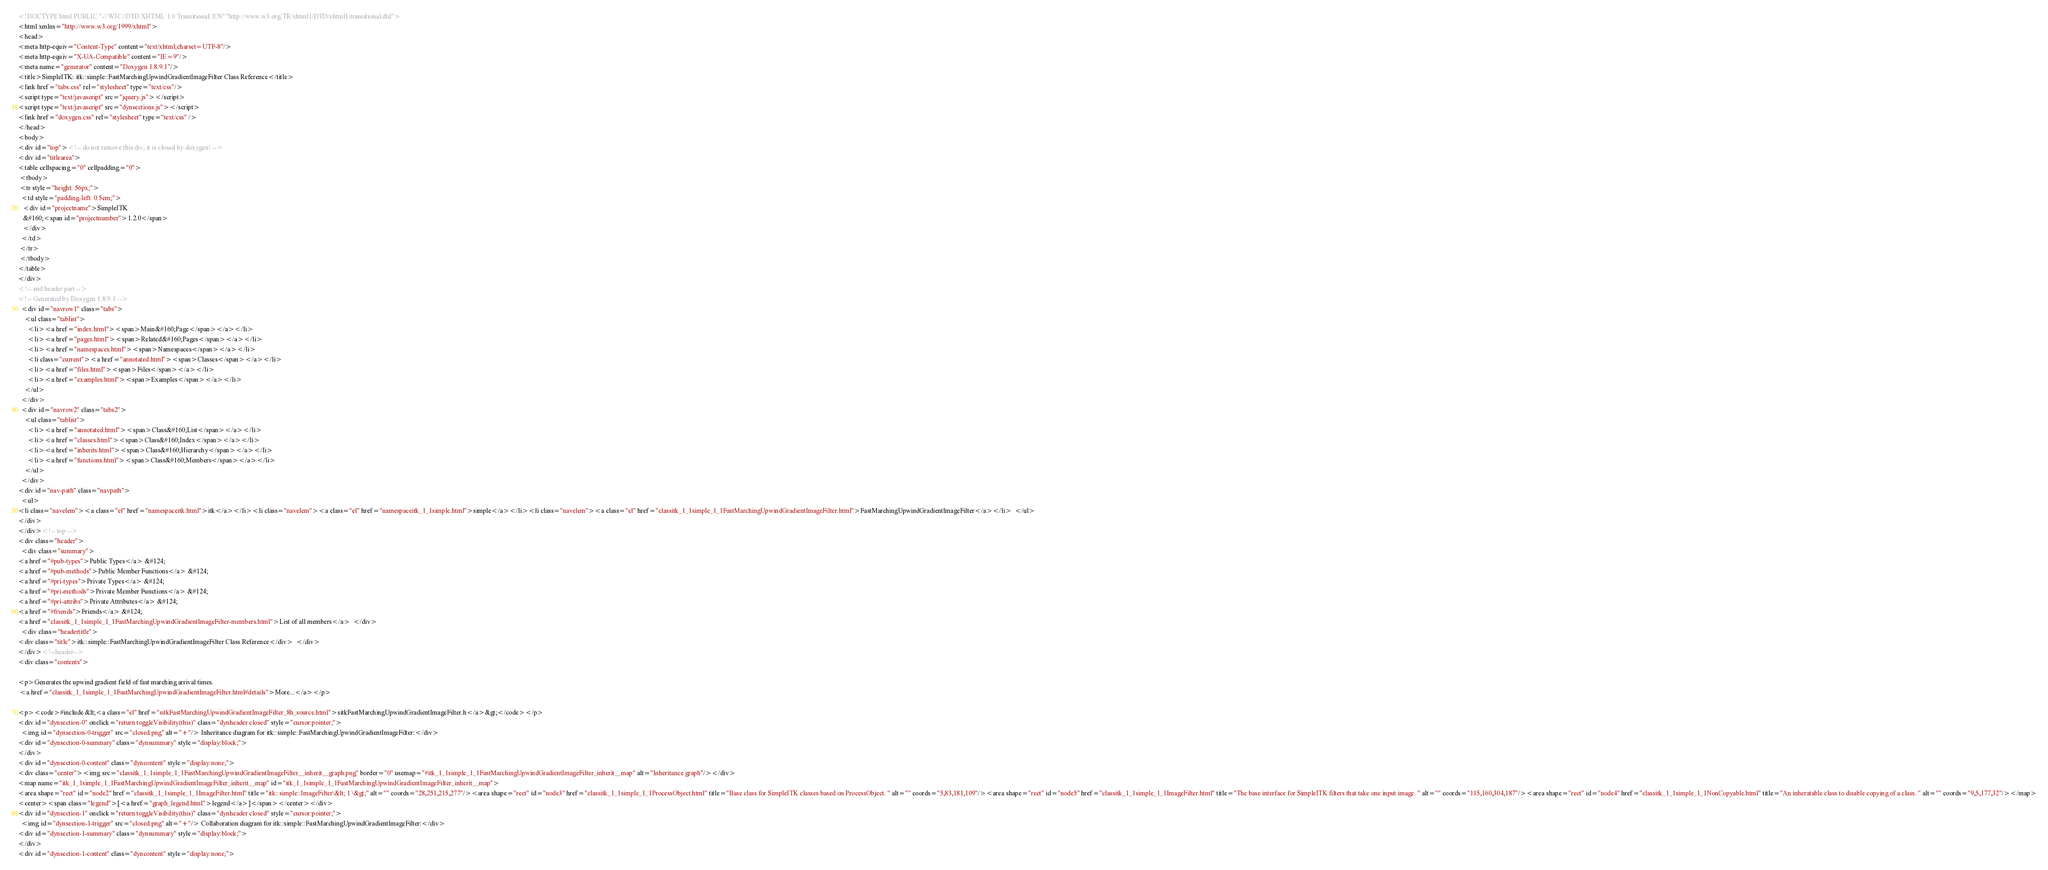Convert code to text. <code><loc_0><loc_0><loc_500><loc_500><_HTML_><!DOCTYPE html PUBLIC "-//W3C//DTD XHTML 1.0 Transitional//EN" "http://www.w3.org/TR/xhtml1/DTD/xhtml1-transitional.dtd">
<html xmlns="http://www.w3.org/1999/xhtml">
<head>
<meta http-equiv="Content-Type" content="text/xhtml;charset=UTF-8"/>
<meta http-equiv="X-UA-Compatible" content="IE=9"/>
<meta name="generator" content="Doxygen 1.8.9.1"/>
<title>SimpleITK: itk::simple::FastMarchingUpwindGradientImageFilter Class Reference</title>
<link href="tabs.css" rel="stylesheet" type="text/css"/>
<script type="text/javascript" src="jquery.js"></script>
<script type="text/javascript" src="dynsections.js"></script>
<link href="doxygen.css" rel="stylesheet" type="text/css" />
</head>
<body>
<div id="top"><!-- do not remove this div, it is closed by doxygen! -->
<div id="titlearea">
<table cellspacing="0" cellpadding="0">
 <tbody>
 <tr style="height: 56px;">
  <td style="padding-left: 0.5em;">
   <div id="projectname">SimpleITK
   &#160;<span id="projectnumber">1.2.0</span>
   </div>
  </td>
 </tr>
 </tbody>
</table>
</div>
<!-- end header part -->
<!-- Generated by Doxygen 1.8.9.1 -->
  <div id="navrow1" class="tabs">
    <ul class="tablist">
      <li><a href="index.html"><span>Main&#160;Page</span></a></li>
      <li><a href="pages.html"><span>Related&#160;Pages</span></a></li>
      <li><a href="namespaces.html"><span>Namespaces</span></a></li>
      <li class="current"><a href="annotated.html"><span>Classes</span></a></li>
      <li><a href="files.html"><span>Files</span></a></li>
      <li><a href="examples.html"><span>Examples</span></a></li>
    </ul>
  </div>
  <div id="navrow2" class="tabs2">
    <ul class="tablist">
      <li><a href="annotated.html"><span>Class&#160;List</span></a></li>
      <li><a href="classes.html"><span>Class&#160;Index</span></a></li>
      <li><a href="inherits.html"><span>Class&#160;Hierarchy</span></a></li>
      <li><a href="functions.html"><span>Class&#160;Members</span></a></li>
    </ul>
  </div>
<div id="nav-path" class="navpath">
  <ul>
<li class="navelem"><a class="el" href="namespaceitk.html">itk</a></li><li class="navelem"><a class="el" href="namespaceitk_1_1simple.html">simple</a></li><li class="navelem"><a class="el" href="classitk_1_1simple_1_1FastMarchingUpwindGradientImageFilter.html">FastMarchingUpwindGradientImageFilter</a></li>  </ul>
</div>
</div><!-- top -->
<div class="header">
  <div class="summary">
<a href="#pub-types">Public Types</a> &#124;
<a href="#pub-methods">Public Member Functions</a> &#124;
<a href="#pri-types">Private Types</a> &#124;
<a href="#pri-methods">Private Member Functions</a> &#124;
<a href="#pri-attribs">Private Attributes</a> &#124;
<a href="#friends">Friends</a> &#124;
<a href="classitk_1_1simple_1_1FastMarchingUpwindGradientImageFilter-members.html">List of all members</a>  </div>
  <div class="headertitle">
<div class="title">itk::simple::FastMarchingUpwindGradientImageFilter Class Reference</div>  </div>
</div><!--header-->
<div class="contents">

<p>Generates the upwind gradient field of fast marching arrival times.  
 <a href="classitk_1_1simple_1_1FastMarchingUpwindGradientImageFilter.html#details">More...</a></p>

<p><code>#include &lt;<a class="el" href="sitkFastMarchingUpwindGradientImageFilter_8h_source.html">sitkFastMarchingUpwindGradientImageFilter.h</a>&gt;</code></p>
<div id="dynsection-0" onclick="return toggleVisibility(this)" class="dynheader closed" style="cursor:pointer;">
  <img id="dynsection-0-trigger" src="closed.png" alt="+"/> Inheritance diagram for itk::simple::FastMarchingUpwindGradientImageFilter:</div>
<div id="dynsection-0-summary" class="dynsummary" style="display:block;">
</div>
<div id="dynsection-0-content" class="dyncontent" style="display:none;">
<div class="center"><img src="classitk_1_1simple_1_1FastMarchingUpwindGradientImageFilter__inherit__graph.png" border="0" usemap="#itk_1_1simple_1_1FastMarchingUpwindGradientImageFilter_inherit__map" alt="Inheritance graph"/></div>
<map name="itk_1_1simple_1_1FastMarchingUpwindGradientImageFilter_inherit__map" id="itk_1_1simple_1_1FastMarchingUpwindGradientImageFilter_inherit__map">
<area shape="rect" id="node2" href="classitk_1_1simple_1_1ImageFilter.html" title="itk::simple::ImageFilter\&lt; 1 \&gt;" alt="" coords="28,251,215,277"/><area shape="rect" id="node3" href="classitk_1_1simple_1_1ProcessObject.html" title="Base class for SimpleITK classes based on ProcessObject. " alt="" coords="5,83,181,109"/><area shape="rect" id="node5" href="classitk_1_1simple_1_1ImageFilter.html" title="The base interface for SimpleITK filters that take one input image. " alt="" coords="115,160,304,187"/><area shape="rect" id="node4" href="classitk_1_1simple_1_1NonCopyable.html" title="An inheratable class to disable copying of a class. " alt="" coords="9,5,177,32"/></map>
<center><span class="legend">[<a href="graph_legend.html">legend</a>]</span></center></div>
<div id="dynsection-1" onclick="return toggleVisibility(this)" class="dynheader closed" style="cursor:pointer;">
  <img id="dynsection-1-trigger" src="closed.png" alt="+"/> Collaboration diagram for itk::simple::FastMarchingUpwindGradientImageFilter:</div>
<div id="dynsection-1-summary" class="dynsummary" style="display:block;">
</div>
<div id="dynsection-1-content" class="dyncontent" style="display:none;"></code> 